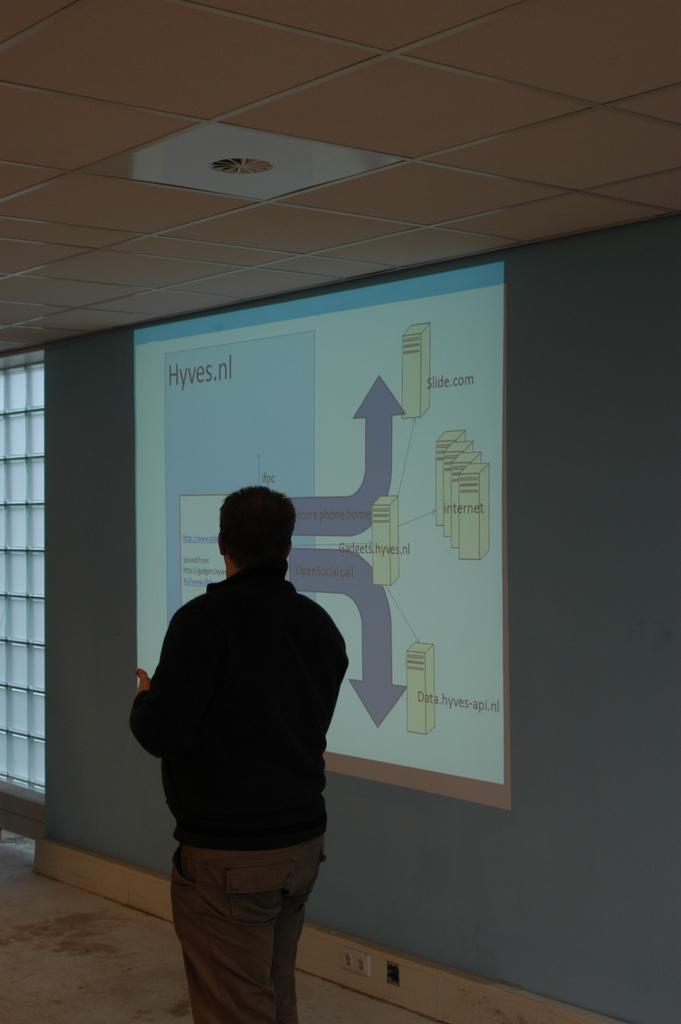Who is present in the image? There is a person in the image. What is the person wearing? The person is wearing a black jacket. What is the person's posture in the image? The person is standing. What can be seen in the background of the image? There is a window, a projection on the wall, and the ceiling visible in the background of the image. What type of dinosaurs can be seen in the image? There are no dinosaurs present in the image. Is there any smoke visible in the image? There is no smoke visible in the image. 